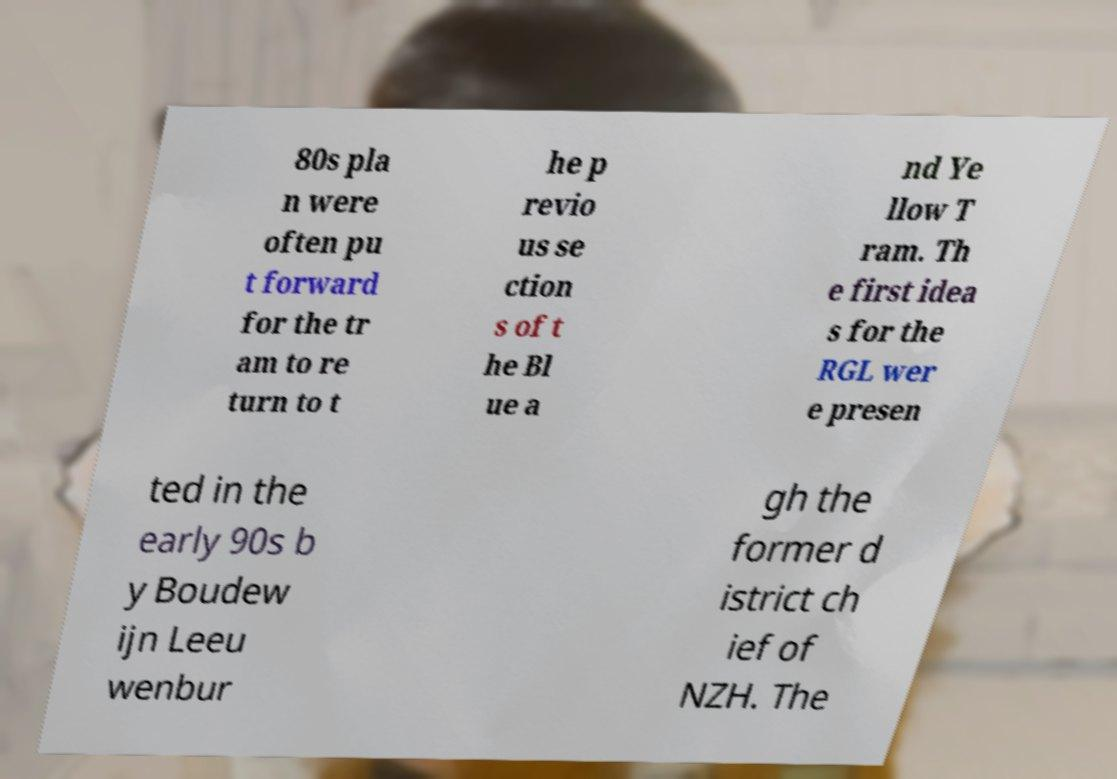Please read and relay the text visible in this image. What does it say? 80s pla n were often pu t forward for the tr am to re turn to t he p revio us se ction s of t he Bl ue a nd Ye llow T ram. Th e first idea s for the RGL wer e presen ted in the early 90s b y Boudew ijn Leeu wenbur gh the former d istrict ch ief of NZH. The 